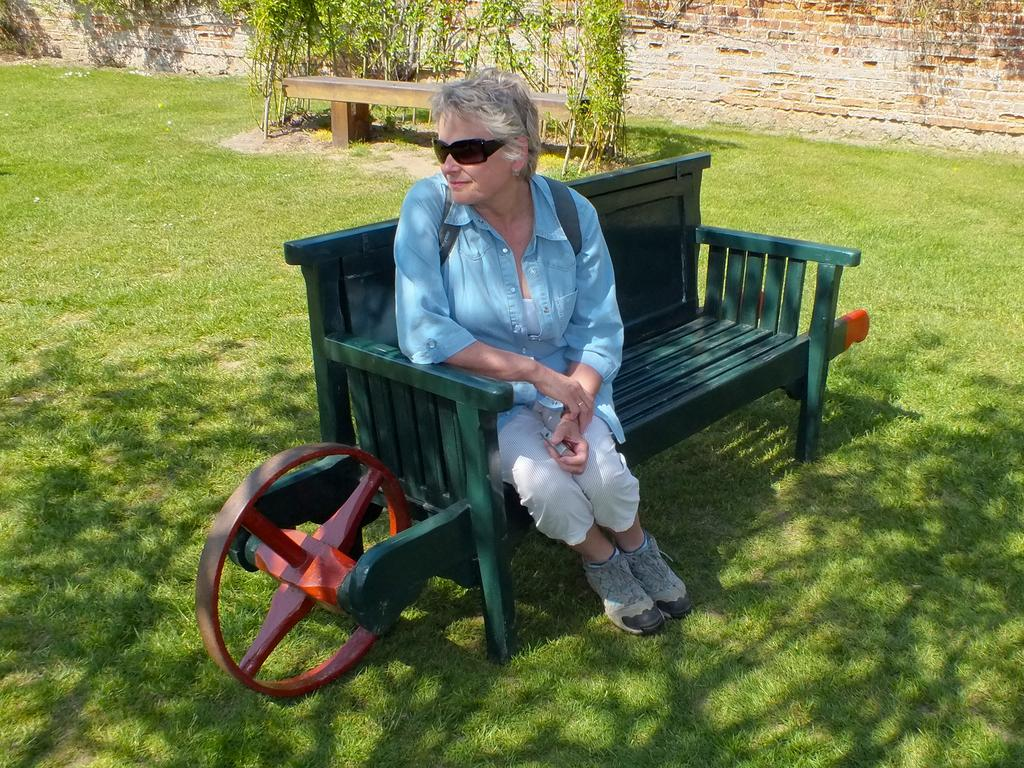Who is the main subject in the image? There is an old woman in the image. What is the old woman doing in the image? The old woman is sitting on a bench. What can be seen in the background of the image? There are plants and a wall in the background of the image. What type of machine is the old woman using in the image? There is no machine present in the image; the old woman is simply sitting on a bench. What kind of gloves is the old woman wearing in the image? The old woman is not wearing any gloves in the image. 